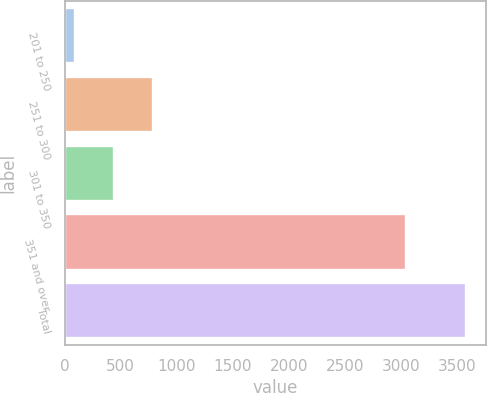Convert chart to OTSL. <chart><loc_0><loc_0><loc_500><loc_500><bar_chart><fcel>201 to 250<fcel>251 to 300<fcel>301 to 350<fcel>351 and over<fcel>Total<nl><fcel>92.6<fcel>790.68<fcel>441.64<fcel>3045.3<fcel>3583<nl></chart> 